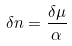Convert formula to latex. <formula><loc_0><loc_0><loc_500><loc_500>\delta n = \frac { \delta \mu } { \alpha }</formula> 